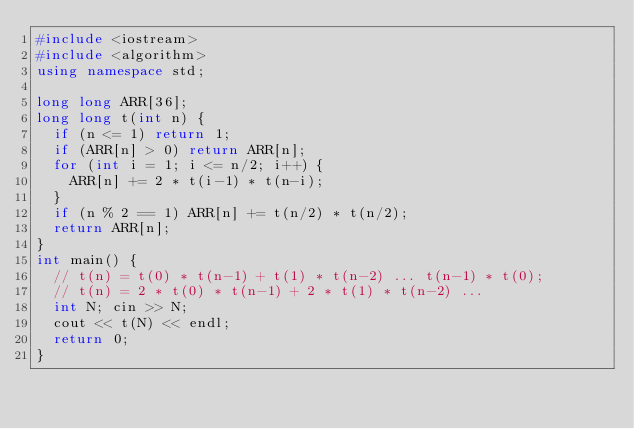<code> <loc_0><loc_0><loc_500><loc_500><_C++_>#include <iostream>
#include <algorithm>
using namespace std;

long long ARR[36];
long long t(int n) {
	if (n <= 1) return 1;
	if (ARR[n] > 0) return ARR[n];
	for (int i = 1; i <= n/2; i++) {
		ARR[n] += 2 * t(i-1) * t(n-i);
	}
	if (n % 2 == 1) ARR[n] += t(n/2) * t(n/2);
	return ARR[n];
}
int main() {
	// t(n) = t(0) * t(n-1) + t(1) * t(n-2) ... t(n-1) * t(0);
	// t(n) = 2 * t(0) * t(n-1) + 2 * t(1) * t(n-2) ... 
	int N; cin >> N;
	cout << t(N) << endl;
	return 0;
}

</code> 